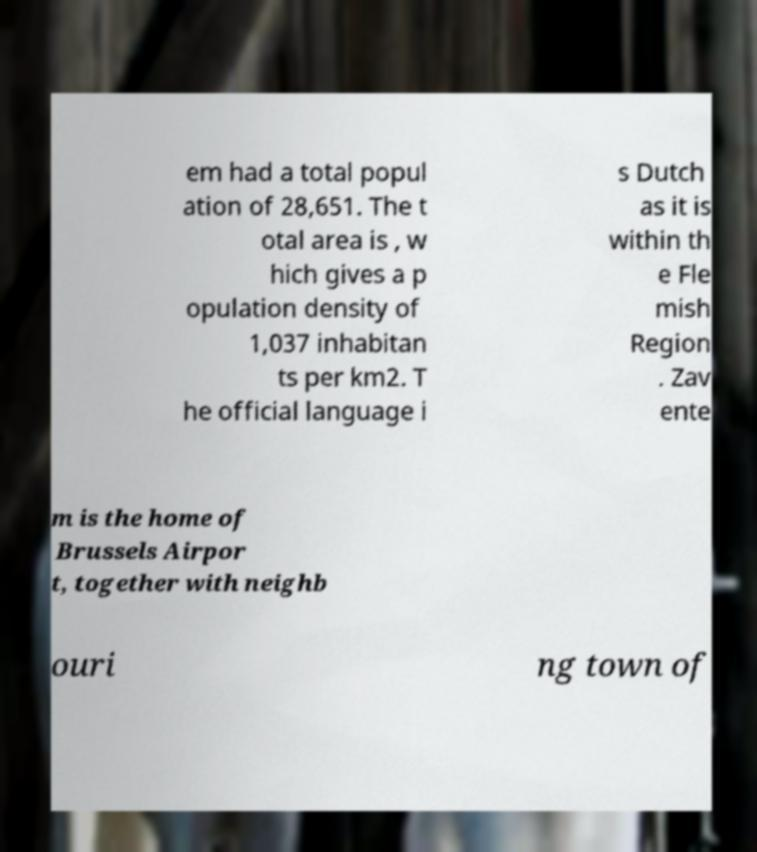Please identify and transcribe the text found in this image. em had a total popul ation of 28,651. The t otal area is , w hich gives a p opulation density of 1,037 inhabitan ts per km2. T he official language i s Dutch as it is within th e Fle mish Region . Zav ente m is the home of Brussels Airpor t, together with neighb ouri ng town of 